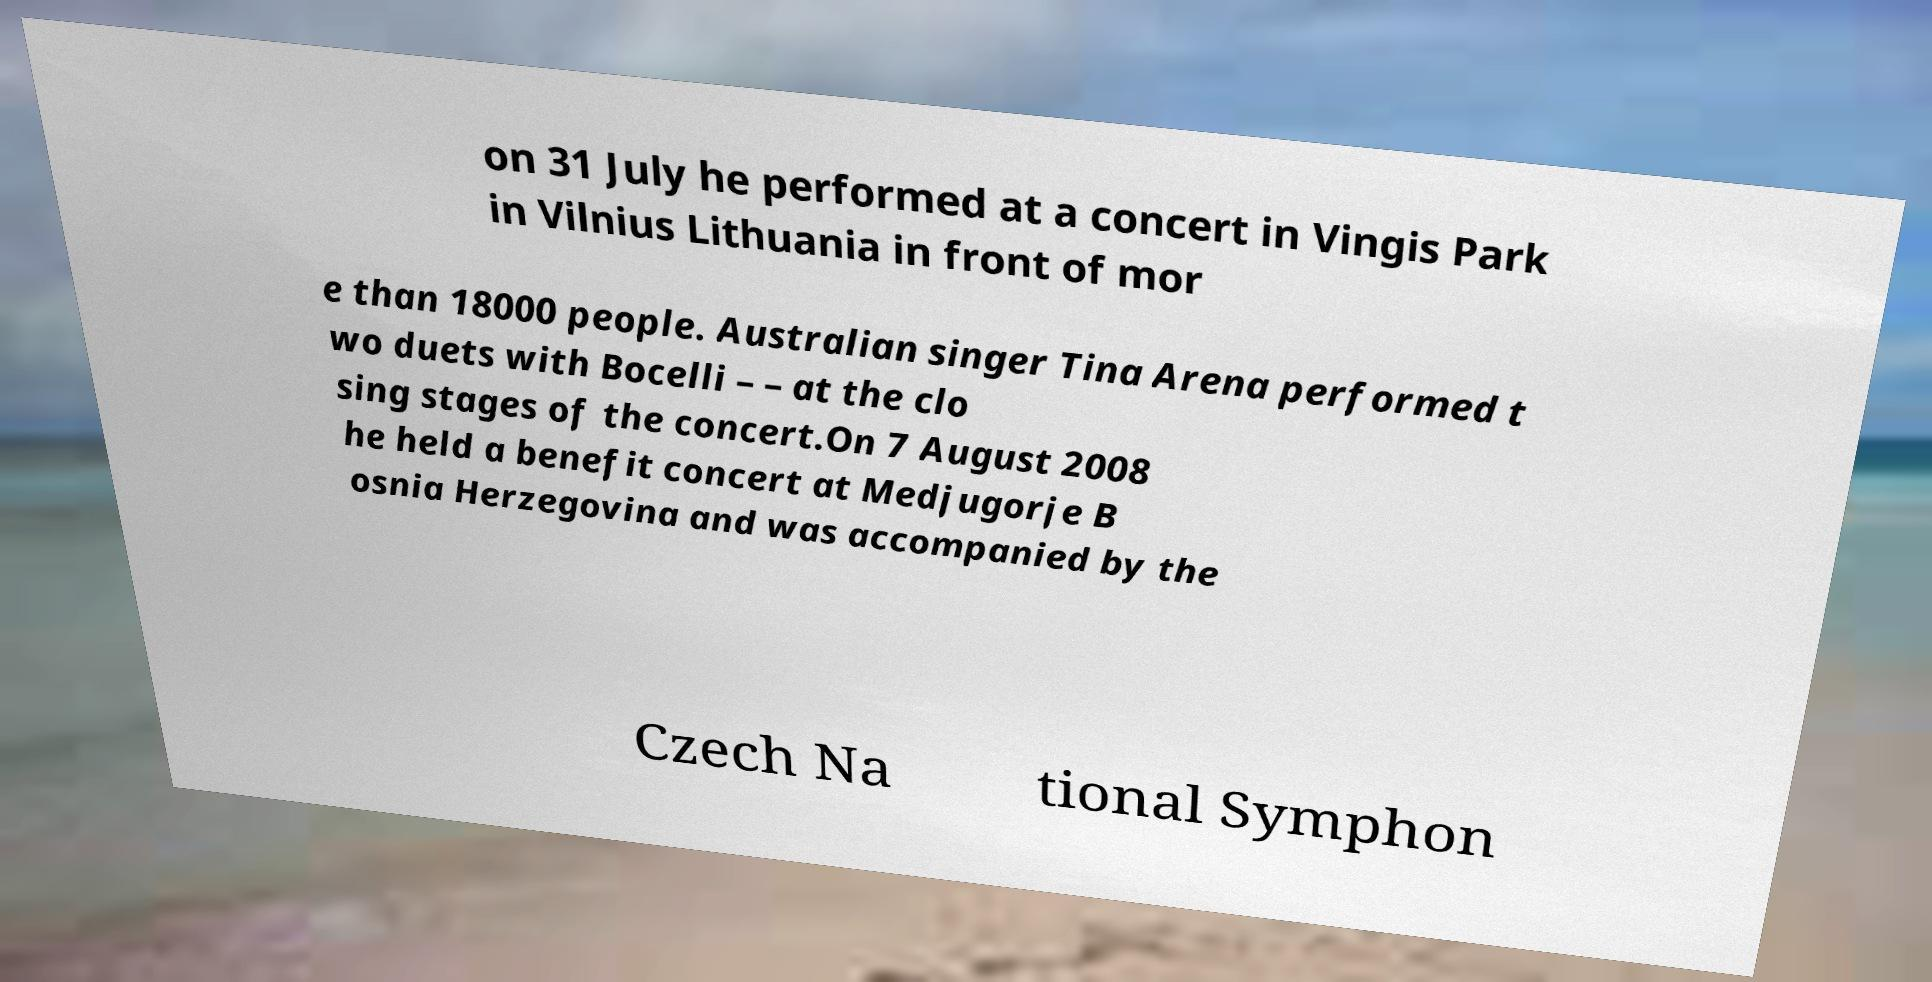Could you extract and type out the text from this image? on 31 July he performed at a concert in Vingis Park in Vilnius Lithuania in front of mor e than 18000 people. Australian singer Tina Arena performed t wo duets with Bocelli – – at the clo sing stages of the concert.On 7 August 2008 he held a benefit concert at Medjugorje B osnia Herzegovina and was accompanied by the Czech Na tional Symphon 